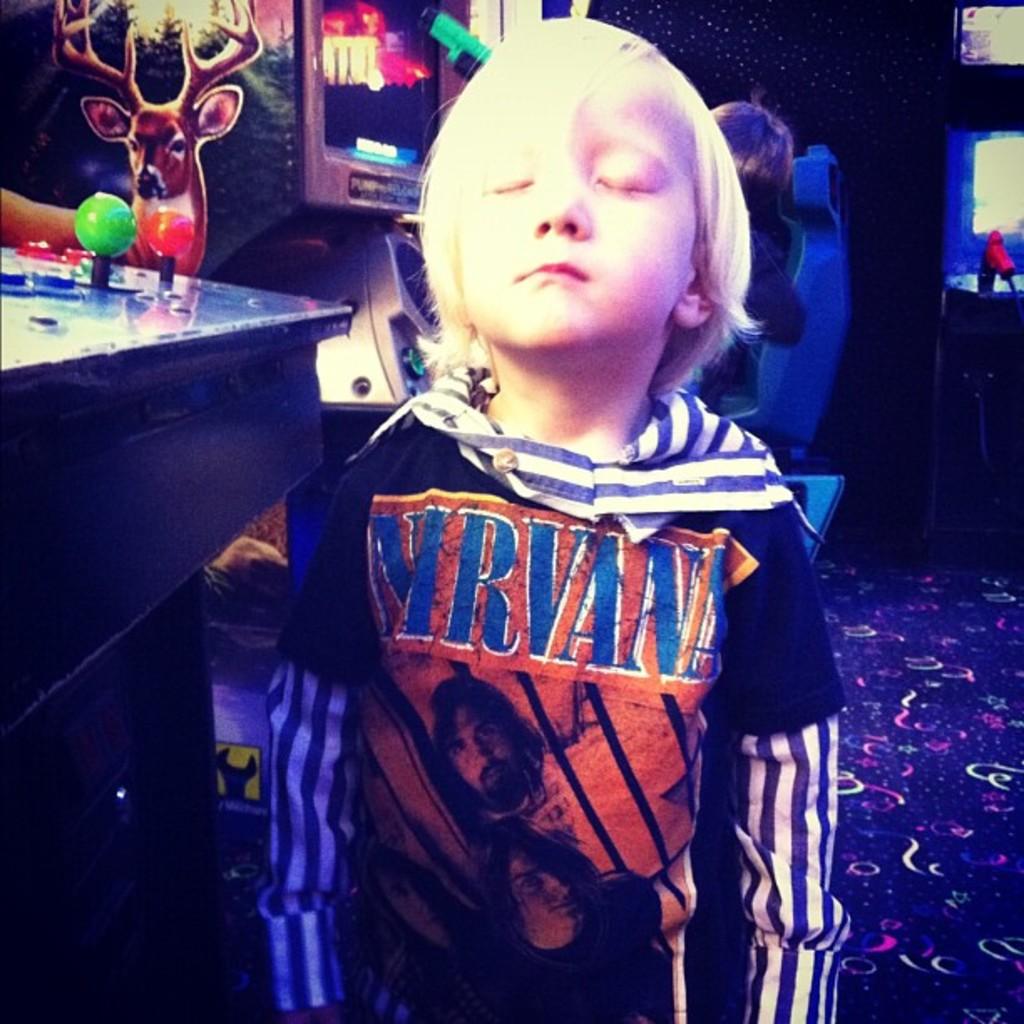Who is shown on this boy's shirt?
Offer a very short reply. Nirvana. What band shirt is the child wearing?
Provide a succinct answer. Nirvana. 